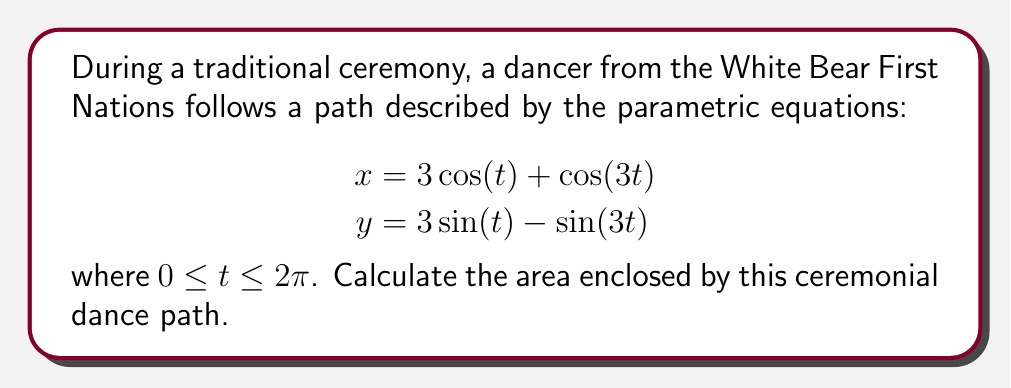Help me with this question. To find the area enclosed by a curve described parametrically, we can use Green's theorem:

$$\text{Area} = \frac{1}{2} \int_C (x dy - y dx)$$

Where $C$ is the closed curve. We can convert this to a single integral with respect to $t$:

$$\text{Area} = \frac{1}{2} \int_0^{2\pi} (x\frac{dy}{dt} - y\frac{dx}{dt}) dt$$

Let's calculate the derivatives:

$$\frac{dx}{dt} = -3\sin(t) - 3\sin(3t)$$
$$\frac{dy}{dt} = 3\cos(t) - 3\cos(3t)$$

Substituting into the integral:

$$\text{Area} = \frac{1}{2} \int_0^{2\pi} [(3\cos(t) + \cos(3t))(3\cos(t) - 3\cos(3t)) - (3\sin(t) - \sin(3t))(-3\sin(t) - 3\sin(3t))] dt$$

Expanding this:

$$\text{Area} = \frac{1}{2} \int_0^{2\pi} [9\cos^2(t) - 9\cos(t)\cos(3t) + 3\cos(t)\cos(3t) - 3\cos^2(3t) + 9\sin^2(t) + 9\sin(t)\sin(3t) - 3\sin(t)\sin(3t) + 3\sin^2(3t)] dt$$

Simplifying:

$$\text{Area} = \frac{1}{2} \int_0^{2\pi} [9\cos^2(t) + 9\sin^2(t) - 6\cos(t)\cos(3t) + 6\sin(t)\sin(3t) - 3\cos^2(3t) + 3\sin^2(3t)] dt$$

Using trigonometric identities:

$$\cos^2(t) + \sin^2(t) = 1$$
$$\cos(t)\cos(3t) + \sin(t)\sin(3t) = \cos(2t)$$
$$\cos^2(3t) + \sin^2(3t) = 1$$

We get:

$$\text{Area} = \frac{1}{2} \int_0^{2\pi} [9 - 6\cos(2t)] dt$$

Integrating:

$$\text{Area} = \frac{1}{2} [9t - 3\sin(2t)]_0^{2\pi}$$

$$\text{Area} = \frac{1}{2} [18\pi - 0] = 9\pi$$

Therefore, the area enclosed by the ceremonial dance path is $9\pi$ square units.
Answer: $9\pi$ square units 